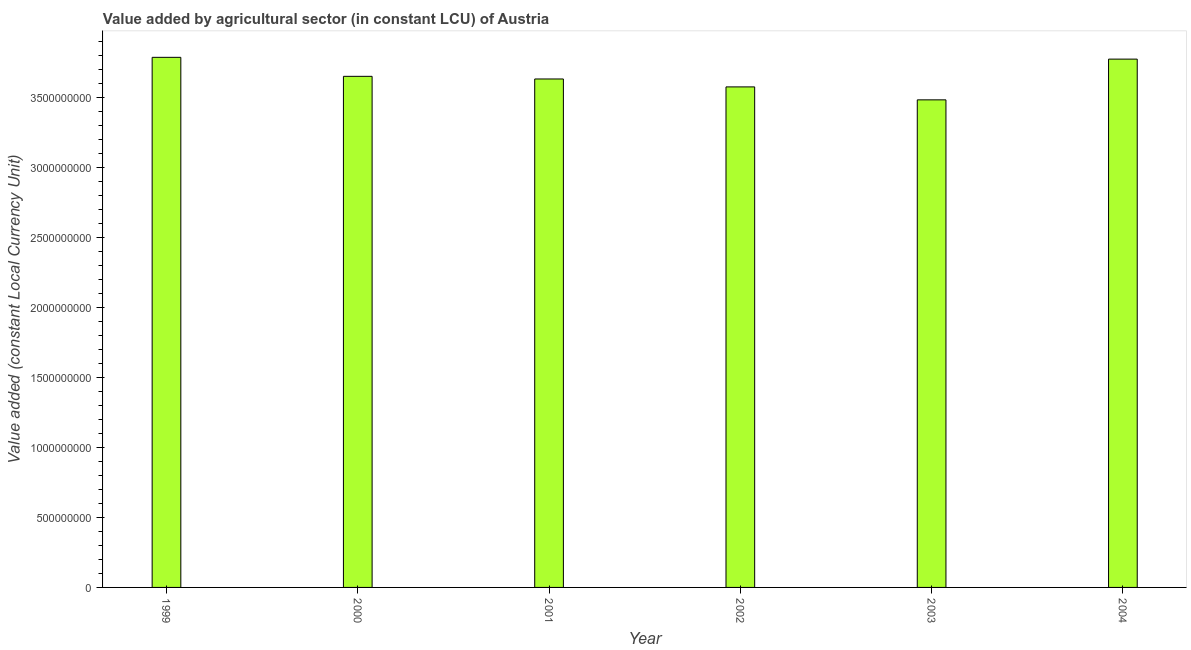Does the graph contain any zero values?
Offer a terse response. No. Does the graph contain grids?
Your answer should be very brief. No. What is the title of the graph?
Make the answer very short. Value added by agricultural sector (in constant LCU) of Austria. What is the label or title of the X-axis?
Ensure brevity in your answer.  Year. What is the label or title of the Y-axis?
Offer a very short reply. Value added (constant Local Currency Unit). What is the value added by agriculture sector in 2000?
Your answer should be compact. 3.65e+09. Across all years, what is the maximum value added by agriculture sector?
Ensure brevity in your answer.  3.78e+09. Across all years, what is the minimum value added by agriculture sector?
Provide a short and direct response. 3.48e+09. In which year was the value added by agriculture sector maximum?
Provide a succinct answer. 1999. In which year was the value added by agriculture sector minimum?
Offer a terse response. 2003. What is the sum of the value added by agriculture sector?
Give a very brief answer. 2.19e+1. What is the difference between the value added by agriculture sector in 2000 and 2002?
Ensure brevity in your answer.  7.54e+07. What is the average value added by agriculture sector per year?
Provide a short and direct response. 3.65e+09. What is the median value added by agriculture sector?
Provide a short and direct response. 3.64e+09. What is the ratio of the value added by agriculture sector in 1999 to that in 2003?
Your answer should be compact. 1.09. Is the value added by agriculture sector in 1999 less than that in 2004?
Provide a short and direct response. No. What is the difference between the highest and the second highest value added by agriculture sector?
Ensure brevity in your answer.  1.27e+07. What is the difference between the highest and the lowest value added by agriculture sector?
Offer a very short reply. 3.04e+08. How many bars are there?
Make the answer very short. 6. Are all the bars in the graph horizontal?
Provide a short and direct response. No. What is the difference between two consecutive major ticks on the Y-axis?
Your response must be concise. 5.00e+08. What is the Value added (constant Local Currency Unit) of 1999?
Give a very brief answer. 3.78e+09. What is the Value added (constant Local Currency Unit) in 2000?
Give a very brief answer. 3.65e+09. What is the Value added (constant Local Currency Unit) in 2001?
Offer a terse response. 3.63e+09. What is the Value added (constant Local Currency Unit) of 2002?
Make the answer very short. 3.57e+09. What is the Value added (constant Local Currency Unit) of 2003?
Give a very brief answer. 3.48e+09. What is the Value added (constant Local Currency Unit) in 2004?
Your answer should be compact. 3.77e+09. What is the difference between the Value added (constant Local Currency Unit) in 1999 and 2000?
Offer a very short reply. 1.36e+08. What is the difference between the Value added (constant Local Currency Unit) in 1999 and 2001?
Offer a very short reply. 1.54e+08. What is the difference between the Value added (constant Local Currency Unit) in 1999 and 2002?
Your answer should be compact. 2.11e+08. What is the difference between the Value added (constant Local Currency Unit) in 1999 and 2003?
Your answer should be very brief. 3.04e+08. What is the difference between the Value added (constant Local Currency Unit) in 1999 and 2004?
Your answer should be very brief. 1.27e+07. What is the difference between the Value added (constant Local Currency Unit) in 2000 and 2001?
Provide a short and direct response. 1.88e+07. What is the difference between the Value added (constant Local Currency Unit) in 2000 and 2002?
Make the answer very short. 7.54e+07. What is the difference between the Value added (constant Local Currency Unit) in 2000 and 2003?
Keep it short and to the point. 1.68e+08. What is the difference between the Value added (constant Local Currency Unit) in 2000 and 2004?
Your response must be concise. -1.23e+08. What is the difference between the Value added (constant Local Currency Unit) in 2001 and 2002?
Offer a terse response. 5.66e+07. What is the difference between the Value added (constant Local Currency Unit) in 2001 and 2003?
Offer a terse response. 1.49e+08. What is the difference between the Value added (constant Local Currency Unit) in 2001 and 2004?
Your response must be concise. -1.42e+08. What is the difference between the Value added (constant Local Currency Unit) in 2002 and 2003?
Offer a terse response. 9.24e+07. What is the difference between the Value added (constant Local Currency Unit) in 2002 and 2004?
Offer a very short reply. -1.98e+08. What is the difference between the Value added (constant Local Currency Unit) in 2003 and 2004?
Your answer should be very brief. -2.91e+08. What is the ratio of the Value added (constant Local Currency Unit) in 1999 to that in 2001?
Provide a short and direct response. 1.04. What is the ratio of the Value added (constant Local Currency Unit) in 1999 to that in 2002?
Your answer should be compact. 1.06. What is the ratio of the Value added (constant Local Currency Unit) in 1999 to that in 2003?
Your answer should be very brief. 1.09. What is the ratio of the Value added (constant Local Currency Unit) in 1999 to that in 2004?
Your answer should be compact. 1. What is the ratio of the Value added (constant Local Currency Unit) in 2000 to that in 2001?
Your answer should be very brief. 1. What is the ratio of the Value added (constant Local Currency Unit) in 2000 to that in 2002?
Keep it short and to the point. 1.02. What is the ratio of the Value added (constant Local Currency Unit) in 2000 to that in 2003?
Provide a short and direct response. 1.05. What is the ratio of the Value added (constant Local Currency Unit) in 2001 to that in 2003?
Provide a short and direct response. 1.04. What is the ratio of the Value added (constant Local Currency Unit) in 2002 to that in 2003?
Provide a short and direct response. 1.03. What is the ratio of the Value added (constant Local Currency Unit) in 2002 to that in 2004?
Provide a short and direct response. 0.95. What is the ratio of the Value added (constant Local Currency Unit) in 2003 to that in 2004?
Keep it short and to the point. 0.92. 